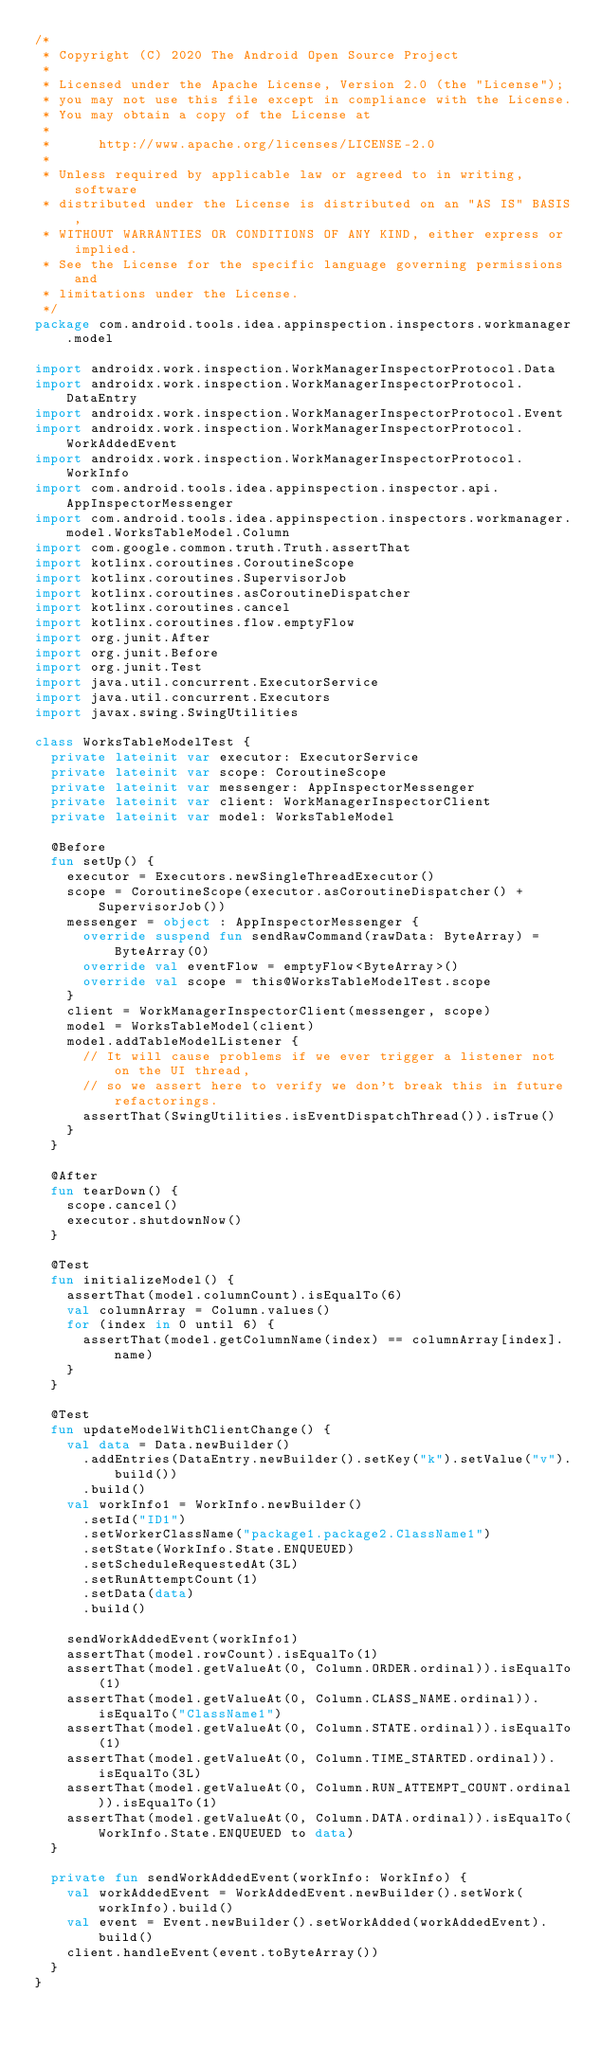<code> <loc_0><loc_0><loc_500><loc_500><_Kotlin_>/*
 * Copyright (C) 2020 The Android Open Source Project
 *
 * Licensed under the Apache License, Version 2.0 (the "License");
 * you may not use this file except in compliance with the License.
 * You may obtain a copy of the License at
 *
 *      http://www.apache.org/licenses/LICENSE-2.0
 *
 * Unless required by applicable law or agreed to in writing, software
 * distributed under the License is distributed on an "AS IS" BASIS,
 * WITHOUT WARRANTIES OR CONDITIONS OF ANY KIND, either express or implied.
 * See the License for the specific language governing permissions and
 * limitations under the License.
 */
package com.android.tools.idea.appinspection.inspectors.workmanager.model

import androidx.work.inspection.WorkManagerInspectorProtocol.Data
import androidx.work.inspection.WorkManagerInspectorProtocol.DataEntry
import androidx.work.inspection.WorkManagerInspectorProtocol.Event
import androidx.work.inspection.WorkManagerInspectorProtocol.WorkAddedEvent
import androidx.work.inspection.WorkManagerInspectorProtocol.WorkInfo
import com.android.tools.idea.appinspection.inspector.api.AppInspectorMessenger
import com.android.tools.idea.appinspection.inspectors.workmanager.model.WorksTableModel.Column
import com.google.common.truth.Truth.assertThat
import kotlinx.coroutines.CoroutineScope
import kotlinx.coroutines.SupervisorJob
import kotlinx.coroutines.asCoroutineDispatcher
import kotlinx.coroutines.cancel
import kotlinx.coroutines.flow.emptyFlow
import org.junit.After
import org.junit.Before
import org.junit.Test
import java.util.concurrent.ExecutorService
import java.util.concurrent.Executors
import javax.swing.SwingUtilities

class WorksTableModelTest {
  private lateinit var executor: ExecutorService
  private lateinit var scope: CoroutineScope
  private lateinit var messenger: AppInspectorMessenger
  private lateinit var client: WorkManagerInspectorClient
  private lateinit var model: WorksTableModel

  @Before
  fun setUp() {
    executor = Executors.newSingleThreadExecutor()
    scope = CoroutineScope(executor.asCoroutineDispatcher() + SupervisorJob())
    messenger = object : AppInspectorMessenger {
      override suspend fun sendRawCommand(rawData: ByteArray) = ByteArray(0)
      override val eventFlow = emptyFlow<ByteArray>()
      override val scope = this@WorksTableModelTest.scope
    }
    client = WorkManagerInspectorClient(messenger, scope)
    model = WorksTableModel(client)
    model.addTableModelListener {
      // It will cause problems if we ever trigger a listener not on the UI thread,
      // so we assert here to verify we don't break this in future refactorings.
      assertThat(SwingUtilities.isEventDispatchThread()).isTrue()
    }
  }

  @After
  fun tearDown() {
    scope.cancel()
    executor.shutdownNow()
  }

  @Test
  fun initializeModel() {
    assertThat(model.columnCount).isEqualTo(6)
    val columnArray = Column.values()
    for (index in 0 until 6) {
      assertThat(model.getColumnName(index) == columnArray[index].name)
    }
  }

  @Test
  fun updateModelWithClientChange() {
    val data = Data.newBuilder()
      .addEntries(DataEntry.newBuilder().setKey("k").setValue("v").build())
      .build()
    val workInfo1 = WorkInfo.newBuilder()
      .setId("ID1")
      .setWorkerClassName("package1.package2.ClassName1")
      .setState(WorkInfo.State.ENQUEUED)
      .setScheduleRequestedAt(3L)
      .setRunAttemptCount(1)
      .setData(data)
      .build()

    sendWorkAddedEvent(workInfo1)
    assertThat(model.rowCount).isEqualTo(1)
    assertThat(model.getValueAt(0, Column.ORDER.ordinal)).isEqualTo(1)
    assertThat(model.getValueAt(0, Column.CLASS_NAME.ordinal)).isEqualTo("ClassName1")
    assertThat(model.getValueAt(0, Column.STATE.ordinal)).isEqualTo(1)
    assertThat(model.getValueAt(0, Column.TIME_STARTED.ordinal)).isEqualTo(3L)
    assertThat(model.getValueAt(0, Column.RUN_ATTEMPT_COUNT.ordinal)).isEqualTo(1)
    assertThat(model.getValueAt(0, Column.DATA.ordinal)).isEqualTo(WorkInfo.State.ENQUEUED to data)
  }

  private fun sendWorkAddedEvent(workInfo: WorkInfo) {
    val workAddedEvent = WorkAddedEvent.newBuilder().setWork(workInfo).build()
    val event = Event.newBuilder().setWorkAdded(workAddedEvent).build()
    client.handleEvent(event.toByteArray())
  }
}
</code> 